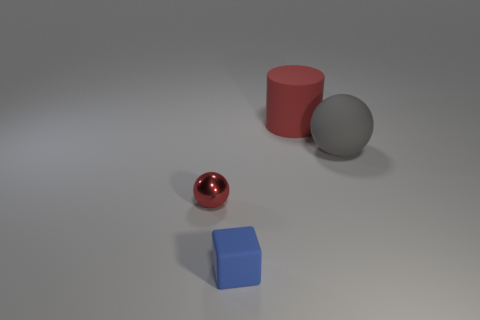There is a red sphere that is the same size as the blue matte cube; what is its material?
Make the answer very short. Metal. Are there an equal number of tiny red shiny objects that are in front of the tiny red metallic object and large balls left of the gray rubber ball?
Make the answer very short. Yes. What number of red shiny spheres are on the left side of the tiny thing behind the matte object in front of the tiny red sphere?
Provide a short and direct response. 0. Is the color of the large rubber cylinder the same as the sphere on the left side of the red rubber thing?
Provide a succinct answer. Yes. The gray thing that is the same material as the big red cylinder is what size?
Your response must be concise. Large. Are there more red objects that are right of the tiny block than green metal cubes?
Offer a terse response. Yes. There is a ball that is to the left of the thing that is in front of the ball to the left of the cube; what is it made of?
Keep it short and to the point. Metal. Do the gray sphere and the thing that is in front of the small red shiny object have the same material?
Your answer should be very brief. Yes. There is a small thing that is the same shape as the large gray rubber object; what material is it?
Your response must be concise. Metal. Is there anything else that is made of the same material as the small red ball?
Offer a terse response. No. 